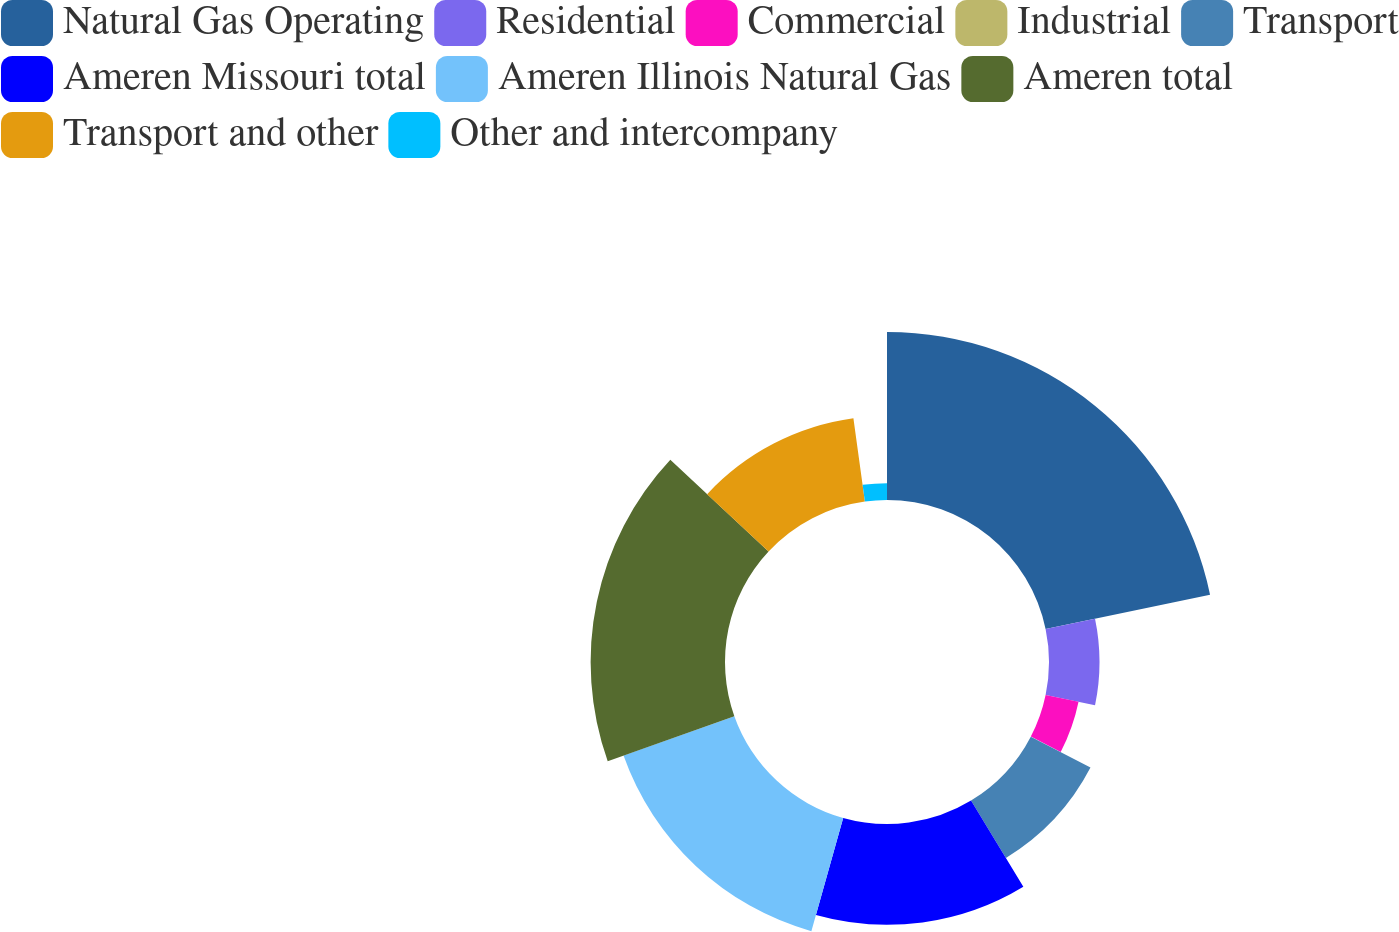<chart> <loc_0><loc_0><loc_500><loc_500><pie_chart><fcel>Natural Gas Operating<fcel>Residential<fcel>Commercial<fcel>Industrial<fcel>Transport<fcel>Ameren Missouri total<fcel>Ameren Illinois Natural Gas<fcel>Ameren total<fcel>Transport and other<fcel>Other and intercompany<nl><fcel>21.73%<fcel>6.53%<fcel>4.35%<fcel>0.01%<fcel>8.7%<fcel>13.04%<fcel>15.21%<fcel>17.38%<fcel>10.87%<fcel>2.18%<nl></chart> 